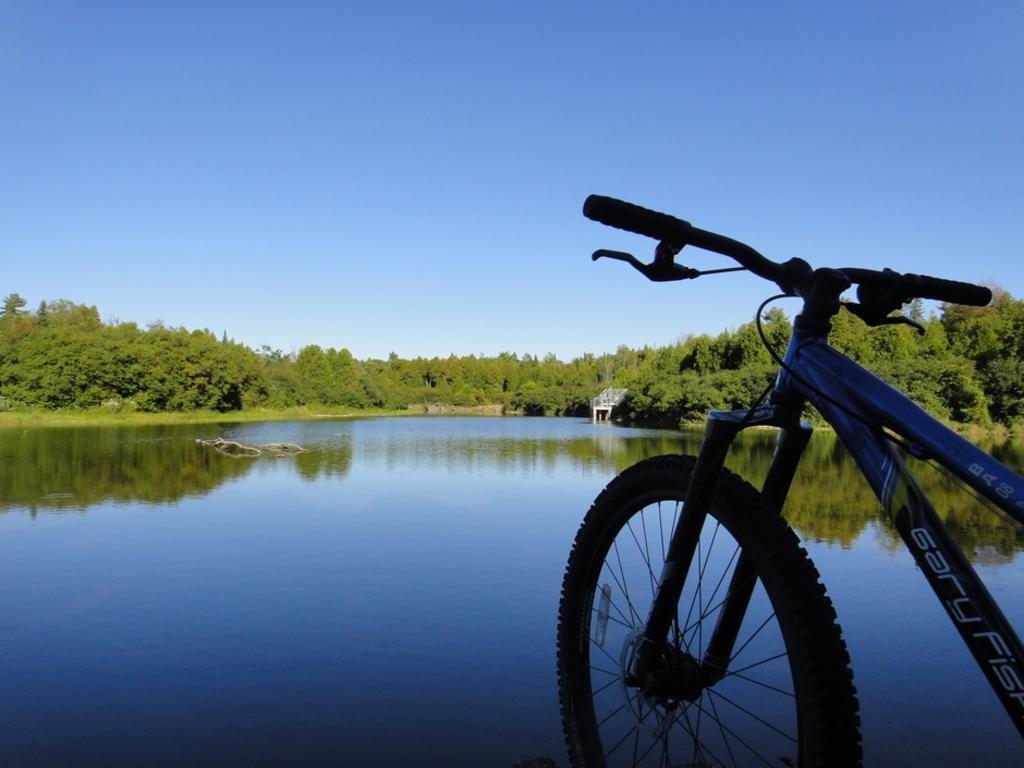What object is located on the right side of the image? There is a bicycle on the right side of the image. What can be seen in the background of the image? Water, trees, and a blue sky are visible in the background of the image. What type of mint is being used to clean the bicycle in the image? There is no mint present in the image, nor is there any indication that the bicycle is being cleaned. 